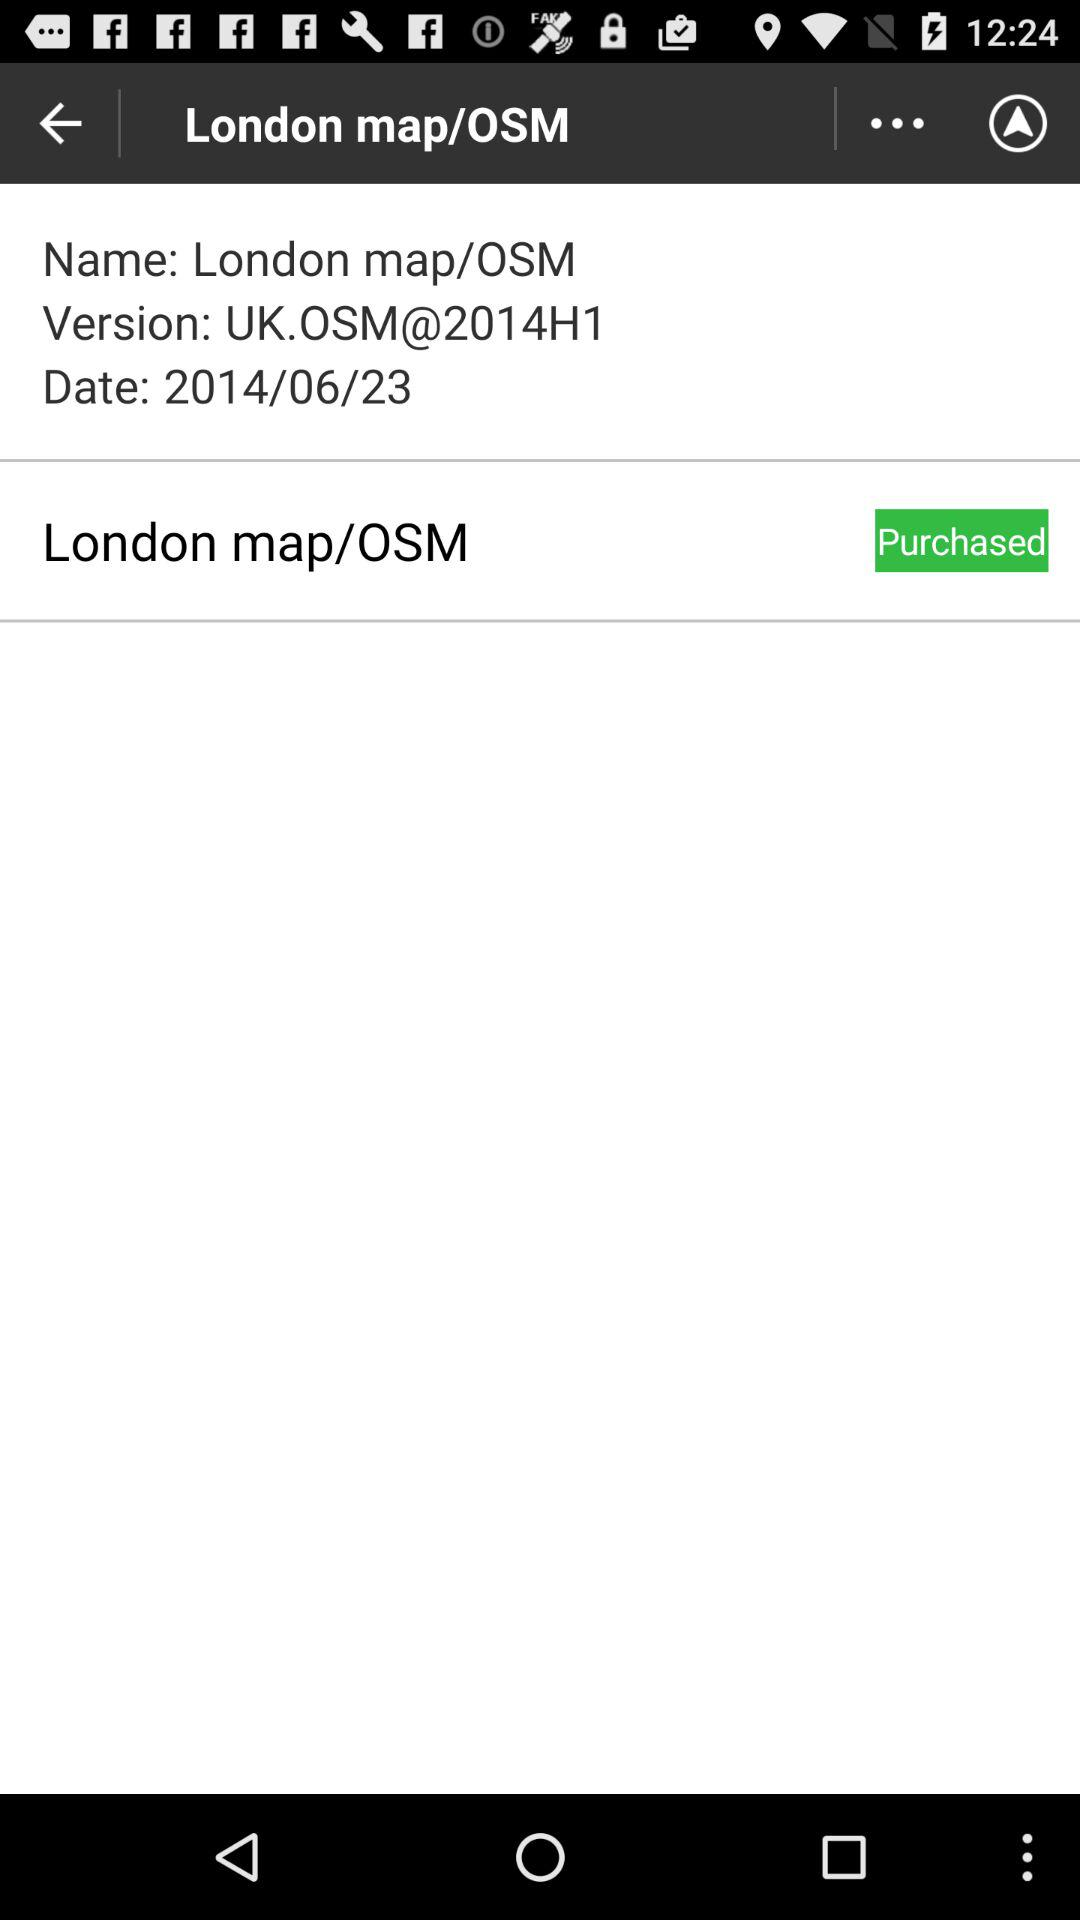What is the name?
Answer the question using a single word or phrase. The name is "London map/OSM", 